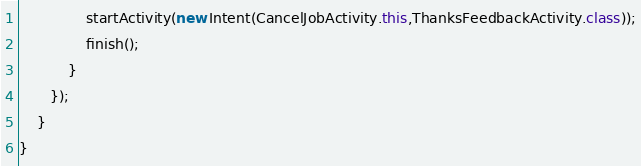<code> <loc_0><loc_0><loc_500><loc_500><_Java_>               startActivity(new Intent(CancelJobActivity.this,ThanksFeedbackActivity.class));
               finish();
           }
       });
    }
}
</code> 